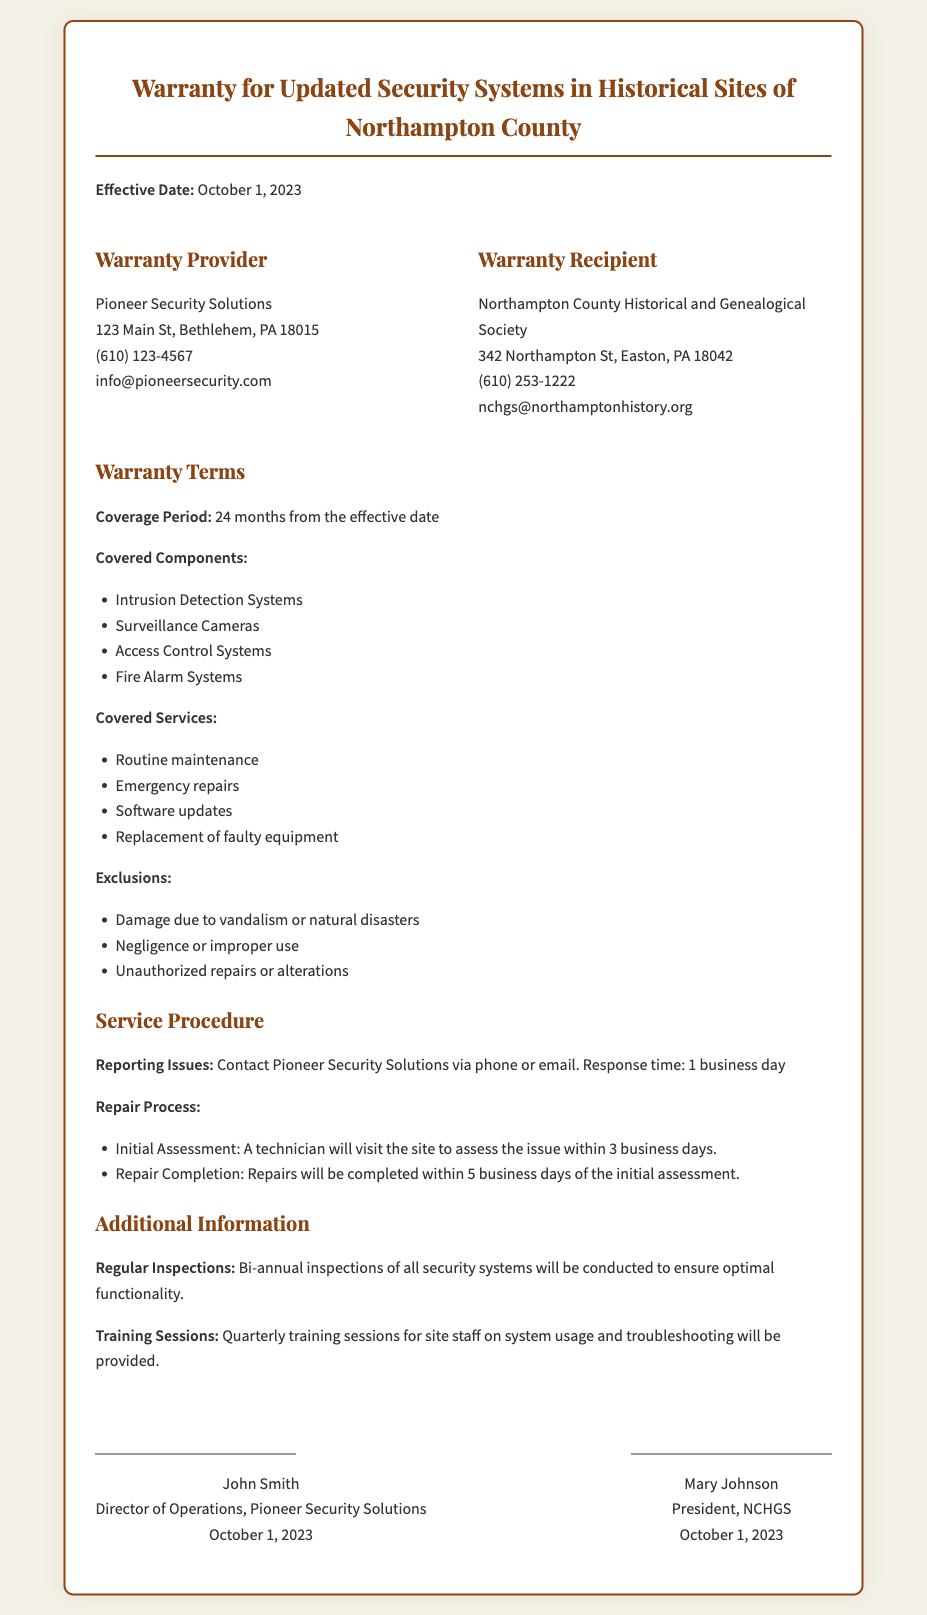what is the effective date of the warranty? The effective date is stated at the beginning of the document, which is October 1, 2023.
Answer: October 1, 2023 who is the warranty provider? The warranty provider's name is given in the document, which is Pioneer Security Solutions.
Answer: Pioneer Security Solutions what is the coverage period for the warranty? The coverage period is mentioned under Warranty Terms, which is 24 months from the effective date.
Answer: 24 months which service is included in the warranty coverage? The document lists several services that are covered, including routine maintenance.
Answer: routine maintenance what is the response time for reporting issues? The response time for issues is stated in the Service Procedure section as 1 business day.
Answer: 1 business day which component is excluded from the warranty? The document lists exclusions, one of which is damage due to vandalism or natural disasters.
Answer: damage due to vandalism or natural disasters how often are regular inspections conducted? The frequency of regular inspections is mentioned as bi-annual in the Additional Information section.
Answer: bi-annual who signed the warranty on behalf of Pioneer Security Solutions? The document specifies the signature of John Smith as the Director of Operations of Pioneer Security Solutions.
Answer: John Smith what is included in the training sessions mentioned in the document? The document specifies the purpose of training as providing sessions for system usage and troubleshooting.
Answer: system usage and troubleshooting 